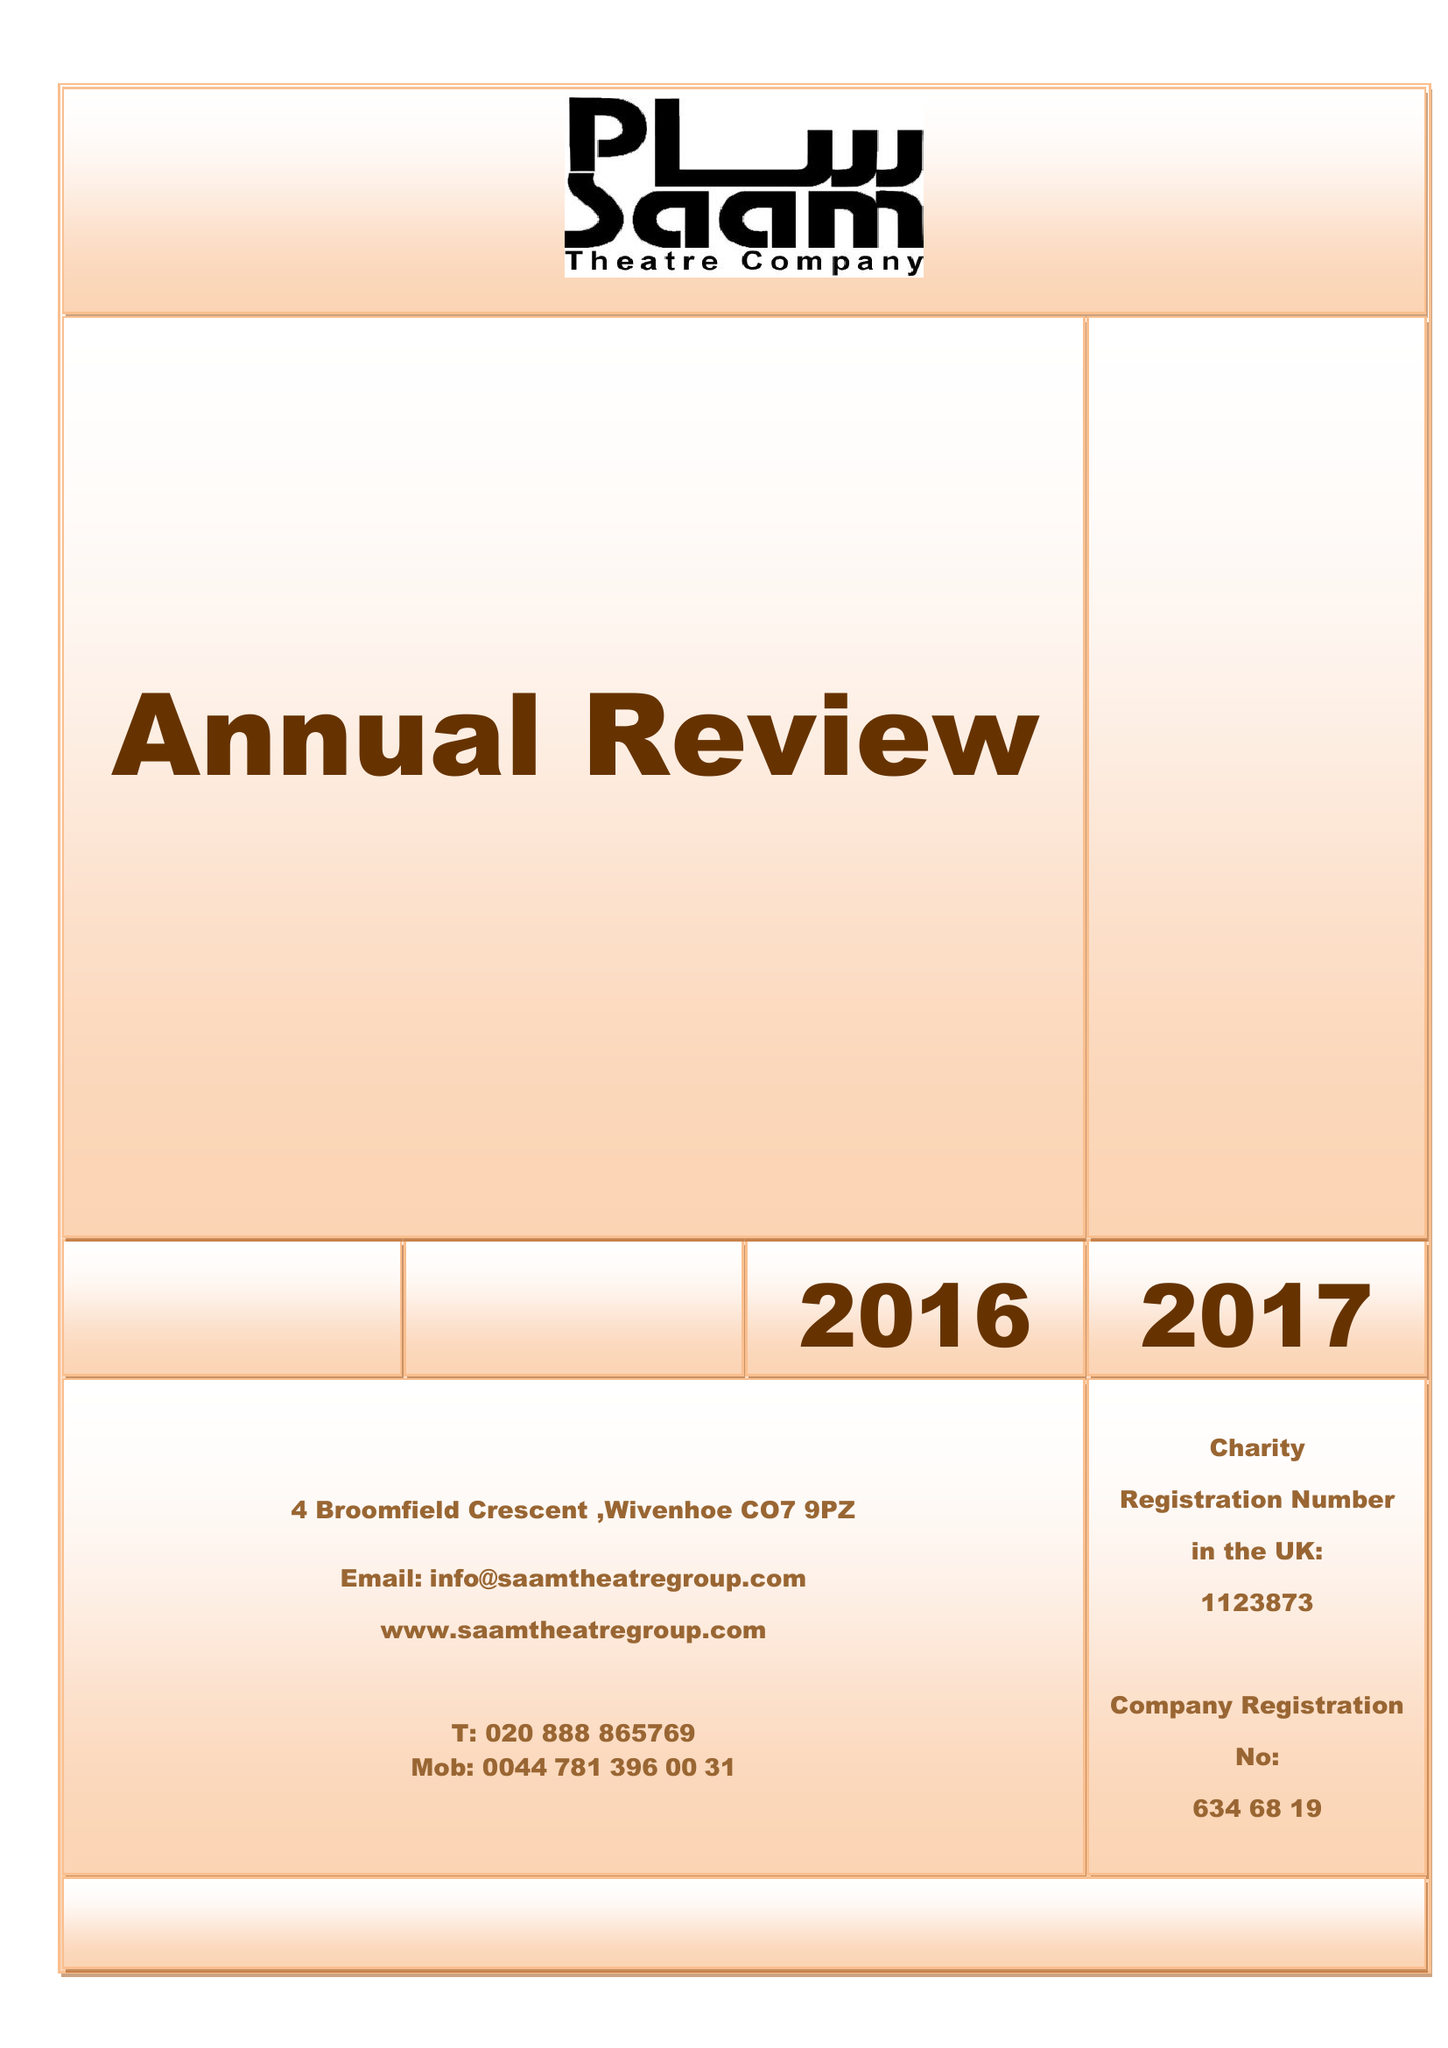What is the value for the spending_annually_in_british_pounds?
Answer the question using a single word or phrase. 30000.00 